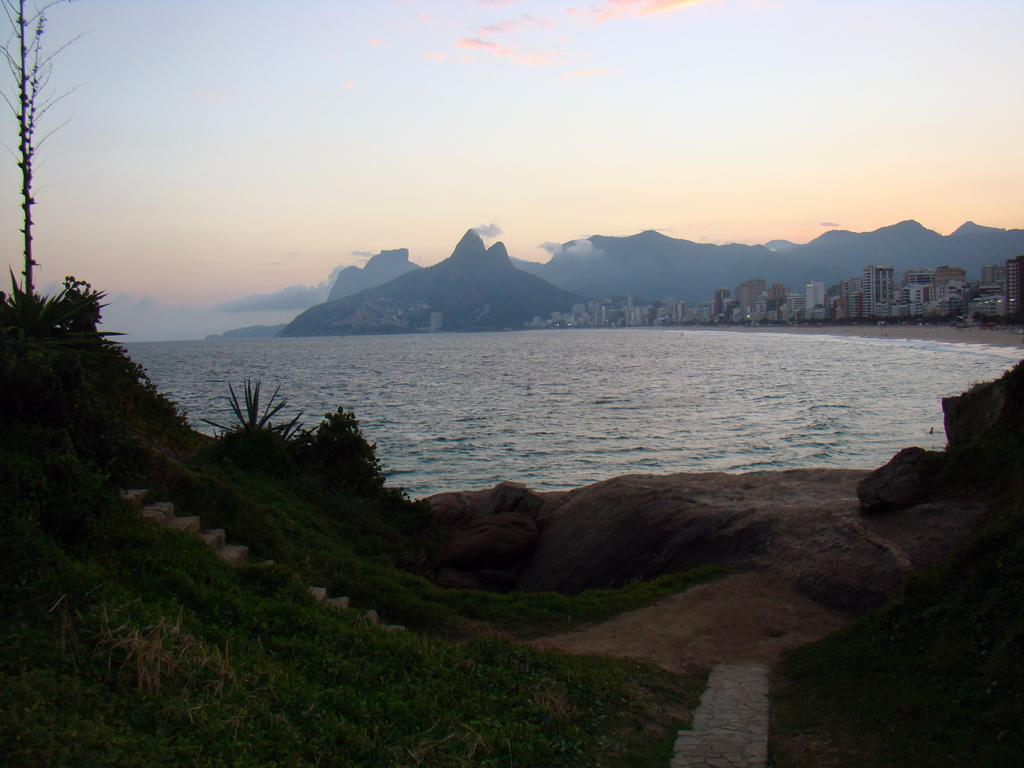What is located in the foreground of the image? There are stones in the foreground of the image. What can be seen in the background of the image? Water, buildings, mountains, and a clear sky are visible in the background of the image. Can you describe the natural elements in the image? The image features stones in the foreground and water in the background. What type of structures are visible in the background? Buildings are visible in the background of the image. What type of throat problem is the frog experiencing in the image? There is no frog present in the image, so it is not possible to determine if it has any throat problems. Is the doll holding a toy in the image? There is no doll present in the image. 